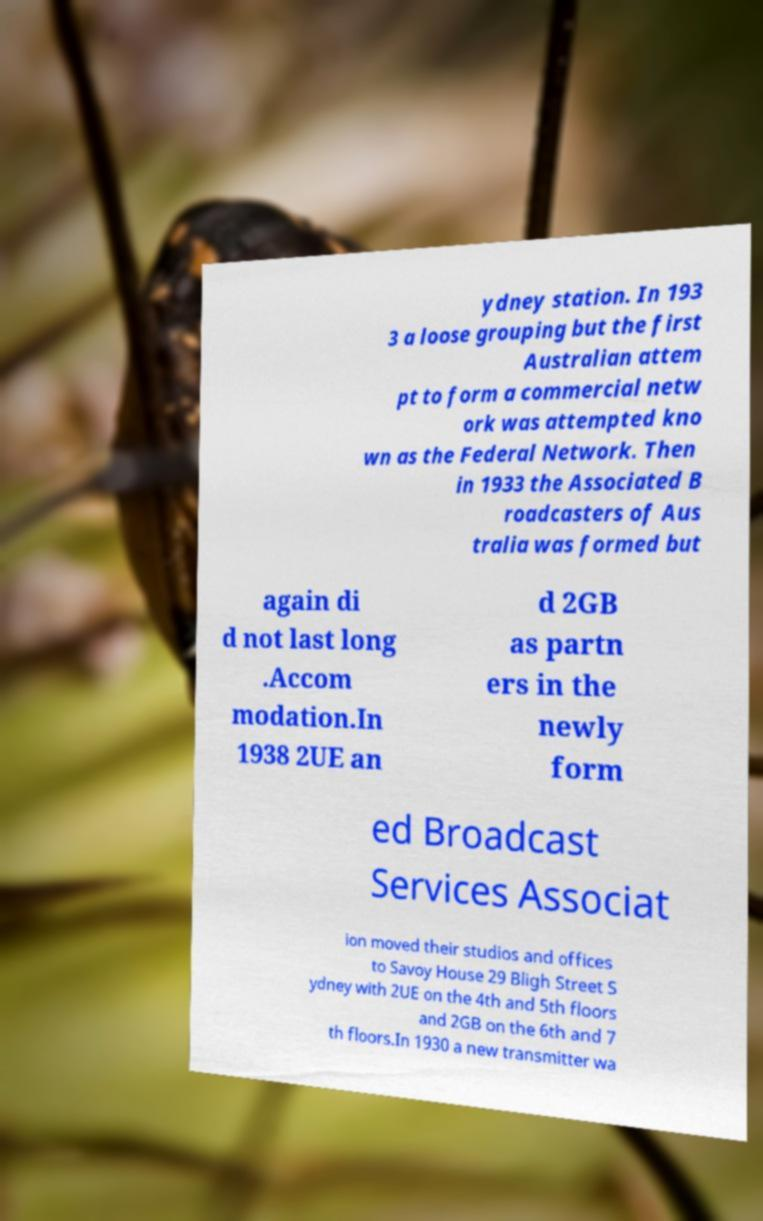There's text embedded in this image that I need extracted. Can you transcribe it verbatim? ydney station. In 193 3 a loose grouping but the first Australian attem pt to form a commercial netw ork was attempted kno wn as the Federal Network. Then in 1933 the Associated B roadcasters of Aus tralia was formed but again di d not last long .Accom modation.In 1938 2UE an d 2GB as partn ers in the newly form ed Broadcast Services Associat ion moved their studios and offices to Savoy House 29 Bligh Street S ydney with 2UE on the 4th and 5th floors and 2GB on the 6th and 7 th floors.In 1930 a new transmitter wa 